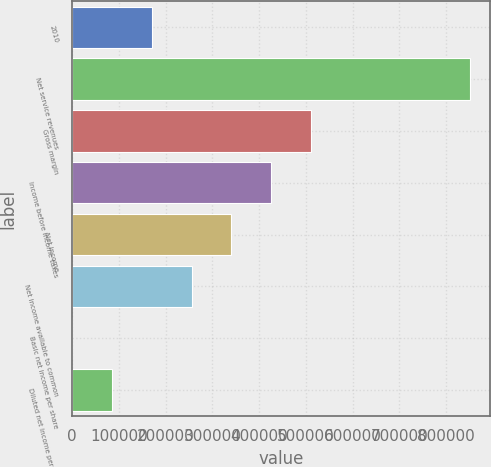<chart> <loc_0><loc_0><loc_500><loc_500><bar_chart><fcel>2010<fcel>Net service revenues<fcel>Gross margin<fcel>Income before income taxes<fcel>Net income<fcel>Net income available to common<fcel>Basic net income per share<fcel>Diluted net income per share<nl><fcel>170315<fcel>851572<fcel>510943<fcel>425786<fcel>340629<fcel>255472<fcel>0.17<fcel>85157.4<nl></chart> 